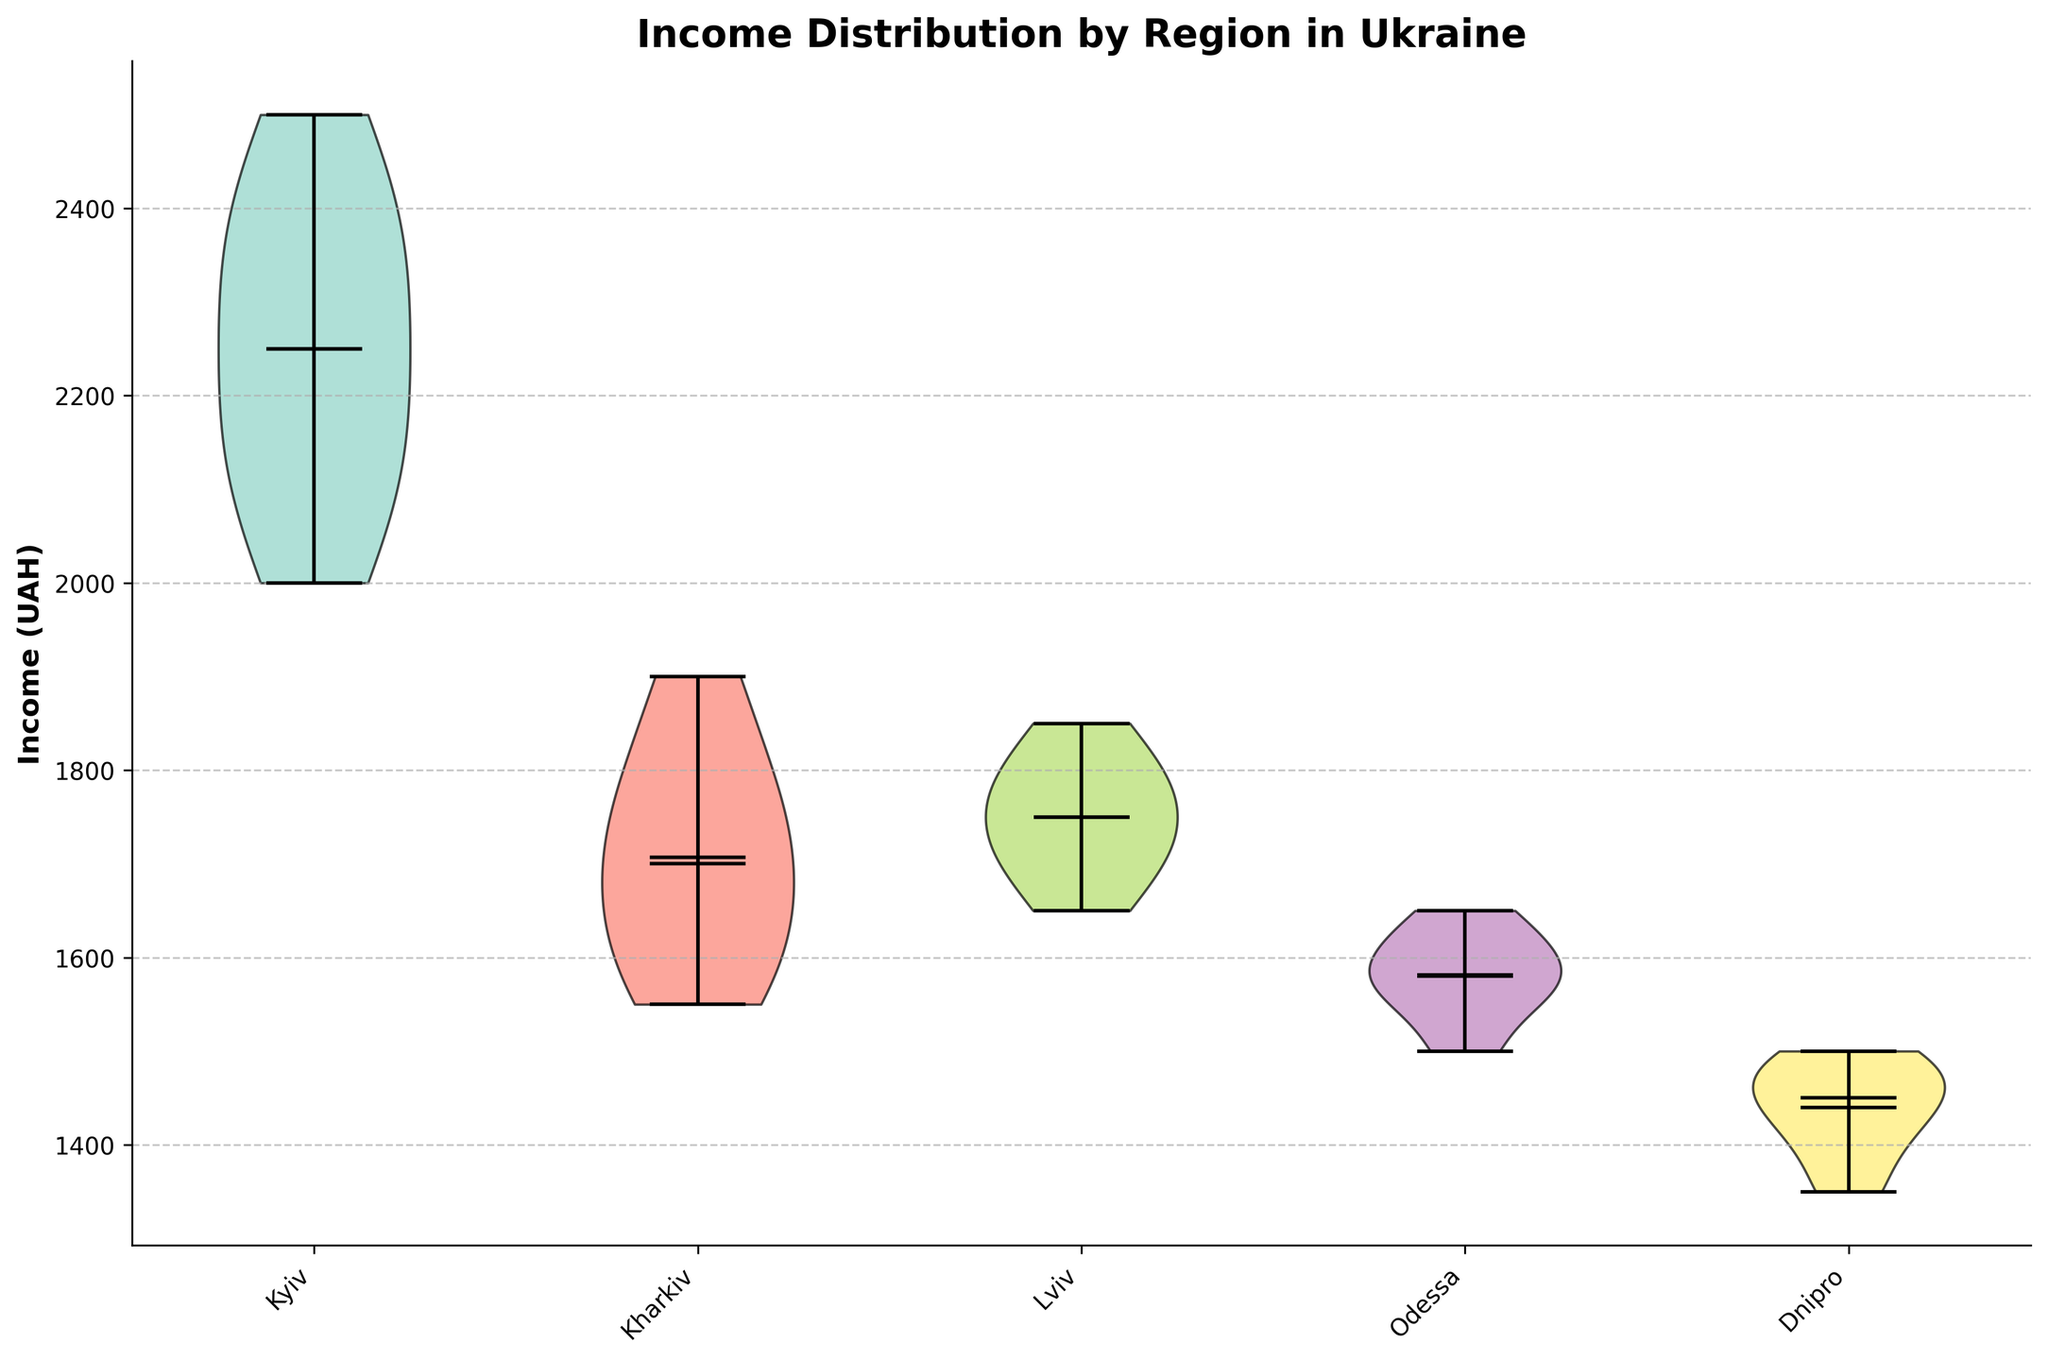Which region has the highest median income? The figure shows the median incomes indicated with lines within each violin plot. The region with the highest median line is Kyiv.
Answer: Kyiv What is the range of incomes in the Kharkiv region? The range can be determined by the top and bottom points of the elongated lines (whiskers) in the Kharkiv violin plot. The top whisker is at 1900 and the bottom whisker is at 1550. So, the range is 1900 - 1550 = 350.
Answer: 350 Which region has the lowest mean income? The figure shows the mean incomes indicated with markers within each violin plot. The region with the lowest mean marker is Dnipro.
Answer: Dnipro Which two regions have the most similar income distributions? By observing the shapes and spreads of the violin plots, Lviv and Kharkiv have the most similar distributions as their violins have comparable widths and ranges.
Answer: Lviv and Kharkiv How does the income distribution in Odessa compare to Kyiv in terms of spread? The spread can be roughly assessed by the width and height of the violin plots. Kyiv has a wider and more varied range compared to Odessa, which means Odessa's distribution is more compact.
Answer: Odessa has a more compact distribution compared to Kyiv What is the median income in Lviv? The median income is indicated by the horizontal line within the violin plot. For Lviv, this line is at 1750.
Answer: 1750 Which region has the broadest income distribution range? The broad range of distribution is indicated by the length of the whiskers. Kyiv shows the widest range from approximately 2000 to 2500.
Answer: Kyiv Is the mean income in Kyiv higher than in Lviv? By comparing the mean markers in the respective violin plots, the mean income in Kyiv is indeed higher than in Lviv.
Answer: Yes How does the income range in Dnipro compare to the income range in Odessa? The range can be determined by the length of the whiskers. Dnipro’s range is from approximately 1350 to 1500, and Odessa’s range is from approximately 1500 to 1650. The range in Odessa is higher.
Answer: The income range in Odessa is higher 